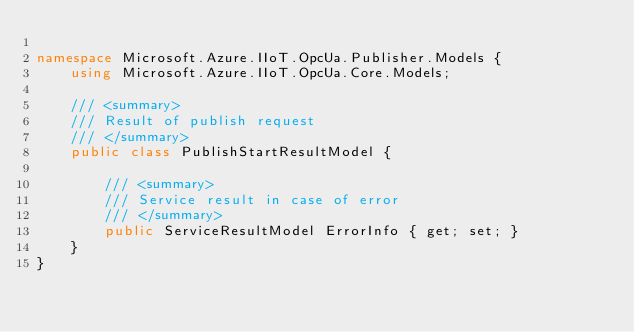Convert code to text. <code><loc_0><loc_0><loc_500><loc_500><_C#_>
namespace Microsoft.Azure.IIoT.OpcUa.Publisher.Models {
    using Microsoft.Azure.IIoT.OpcUa.Core.Models;

    /// <summary>
    /// Result of publish request
    /// </summary>
    public class PublishStartResultModel {

        /// <summary>
        /// Service result in case of error
        /// </summary>
        public ServiceResultModel ErrorInfo { get; set; }
    }
}
</code> 